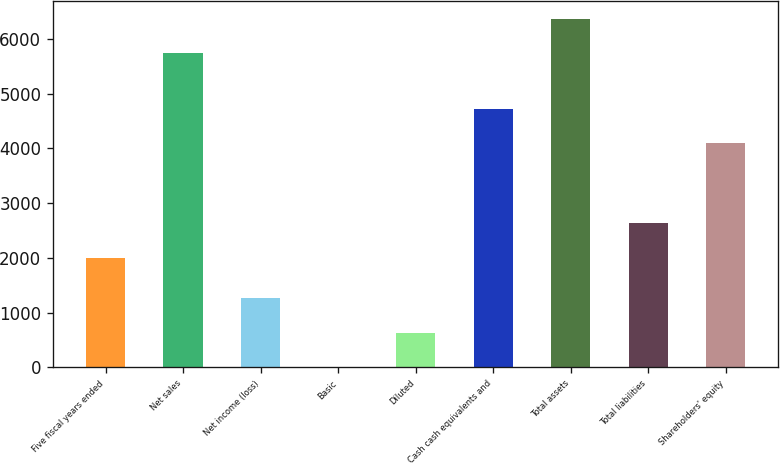<chart> <loc_0><loc_0><loc_500><loc_500><bar_chart><fcel>Five fiscal years ended<fcel>Net sales<fcel>Net income (loss)<fcel>Basic<fcel>Diluted<fcel>Cash cash equivalents and<fcel>Total assets<fcel>Total liabilities<fcel>Shareholders' equity<nl><fcel>2002<fcel>5742<fcel>1259.74<fcel>0.18<fcel>629.96<fcel>4724.78<fcel>6371.78<fcel>2631.78<fcel>4095<nl></chart> 